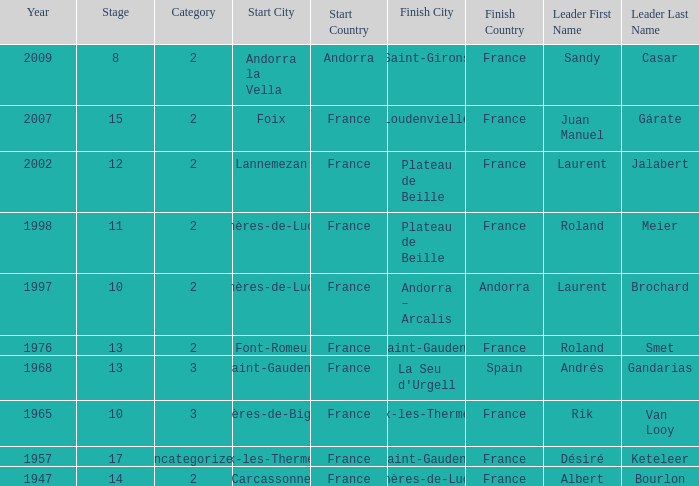Give the Finish for years after 2007. Saint-Girons. 